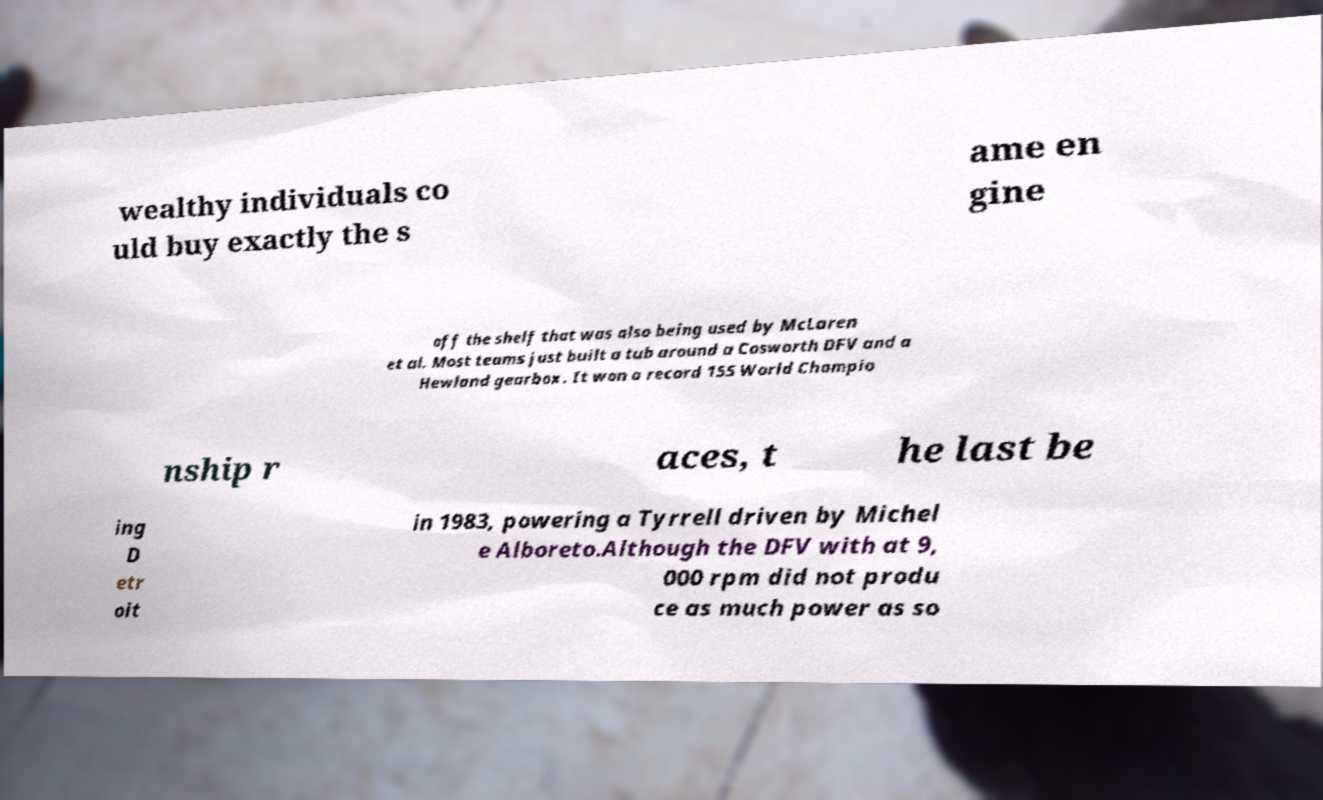Could you assist in decoding the text presented in this image and type it out clearly? wealthy individuals co uld buy exactly the s ame en gine off the shelf that was also being used by McLaren et al. Most teams just built a tub around a Cosworth DFV and a Hewland gearbox. It won a record 155 World Champio nship r aces, t he last be ing D etr oit in 1983, powering a Tyrrell driven by Michel e Alboreto.Although the DFV with at 9, 000 rpm did not produ ce as much power as so 